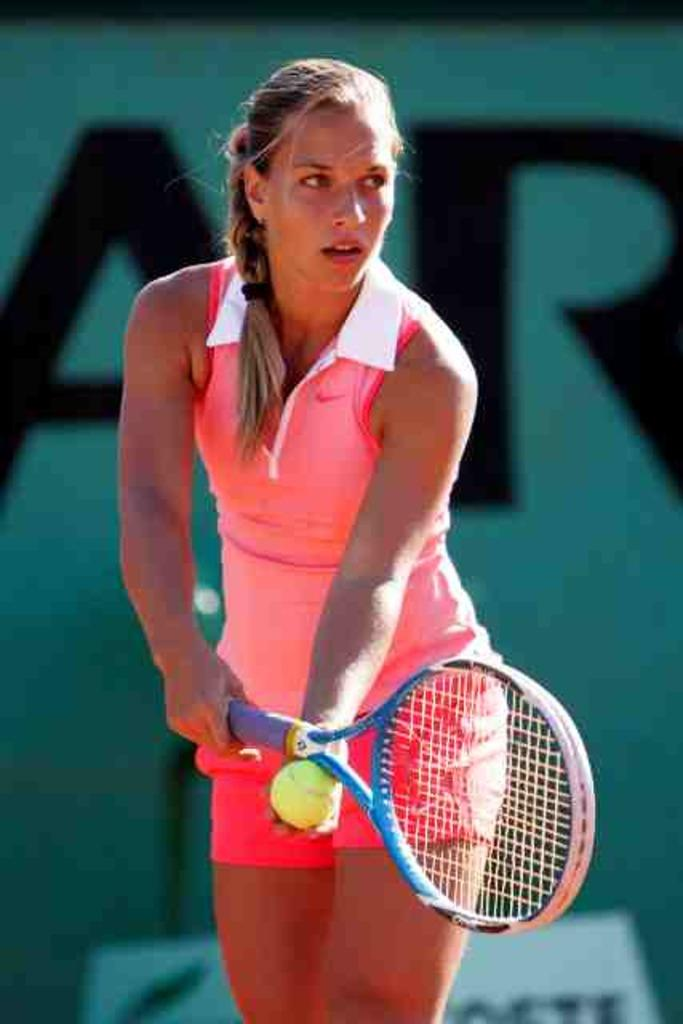Who is the main subject in the image? There is a lady in the image. What is the lady doing in the image? The lady is playing tennis. What can be seen in the background of the image? There is a poster named AR in the background of the image. Can you see a cat playing with a ball of yarn in the image? There is no cat or ball of yarn present in the image. How many trains are visible in the image? There are no trains visible in the image. 